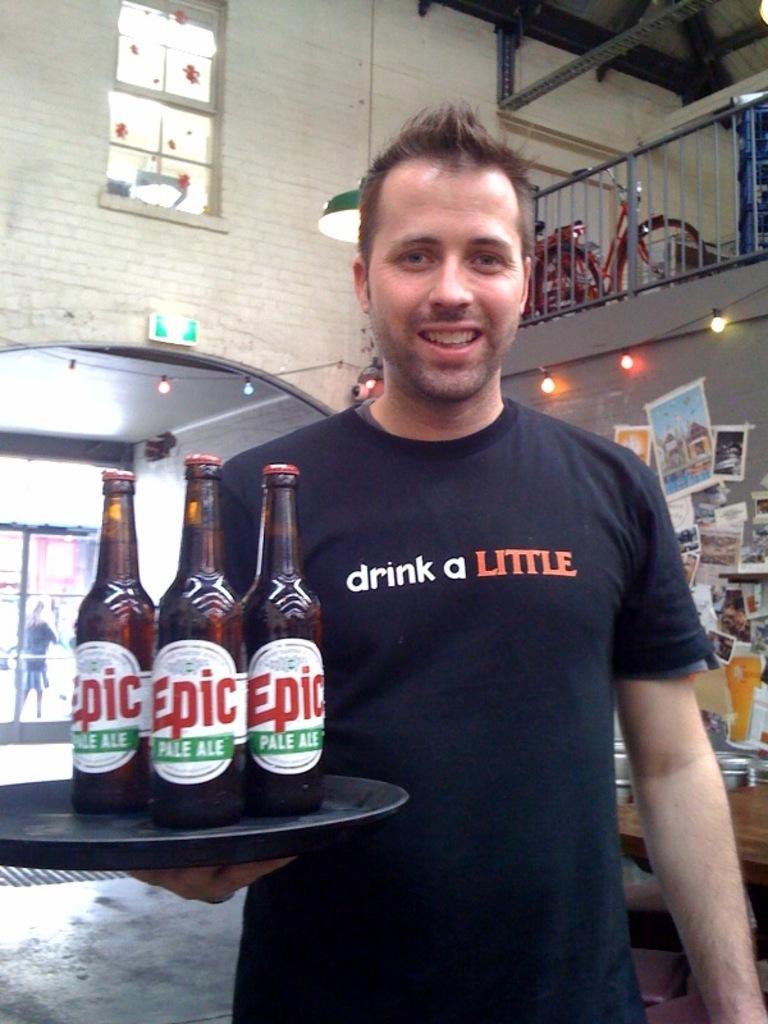What does his shirt say?
Make the answer very short. Drink a little. 